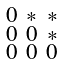Convert formula to latex. <formula><loc_0><loc_0><loc_500><loc_500>\begin{smallmatrix} 0 & * & * \\ 0 & 0 & * \\ 0 & 0 & 0 \end{smallmatrix}</formula> 